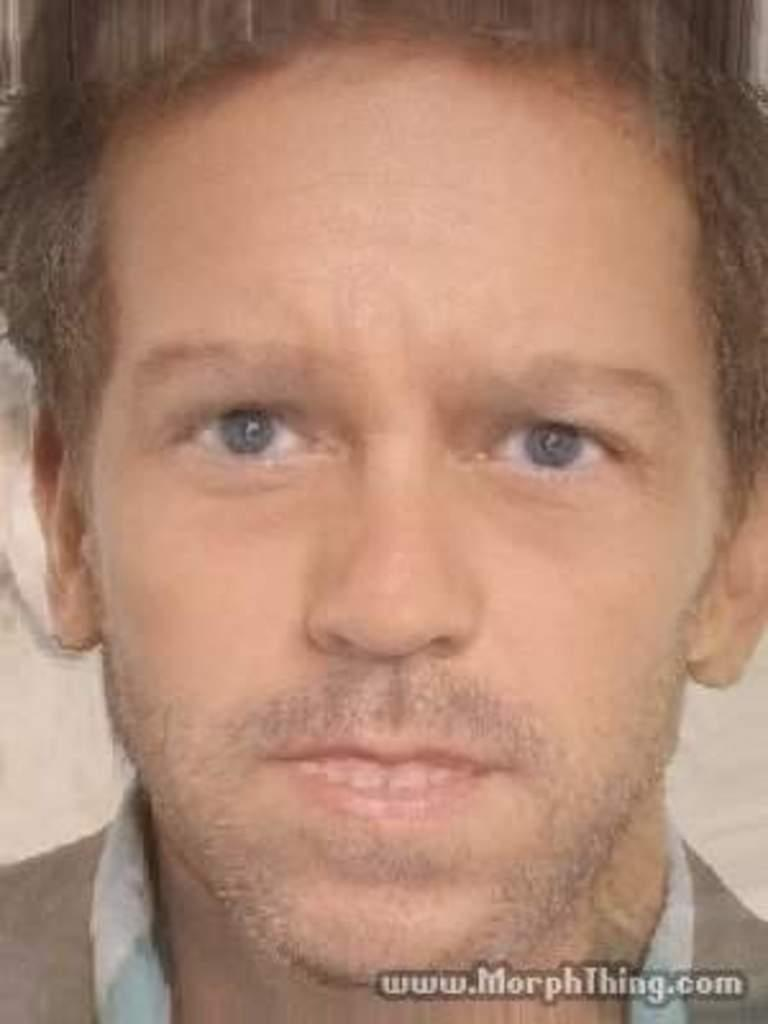Who is the main subject in the image? There is a man in the center of the image. What else can be seen in the image besides the man? There is text at the bottom of the image. What type of waves can be seen crashing against the shore in the image? There are no waves present in the image; it features a man and text. How many hooks are visible in the image? There are no hooks present in the image. 